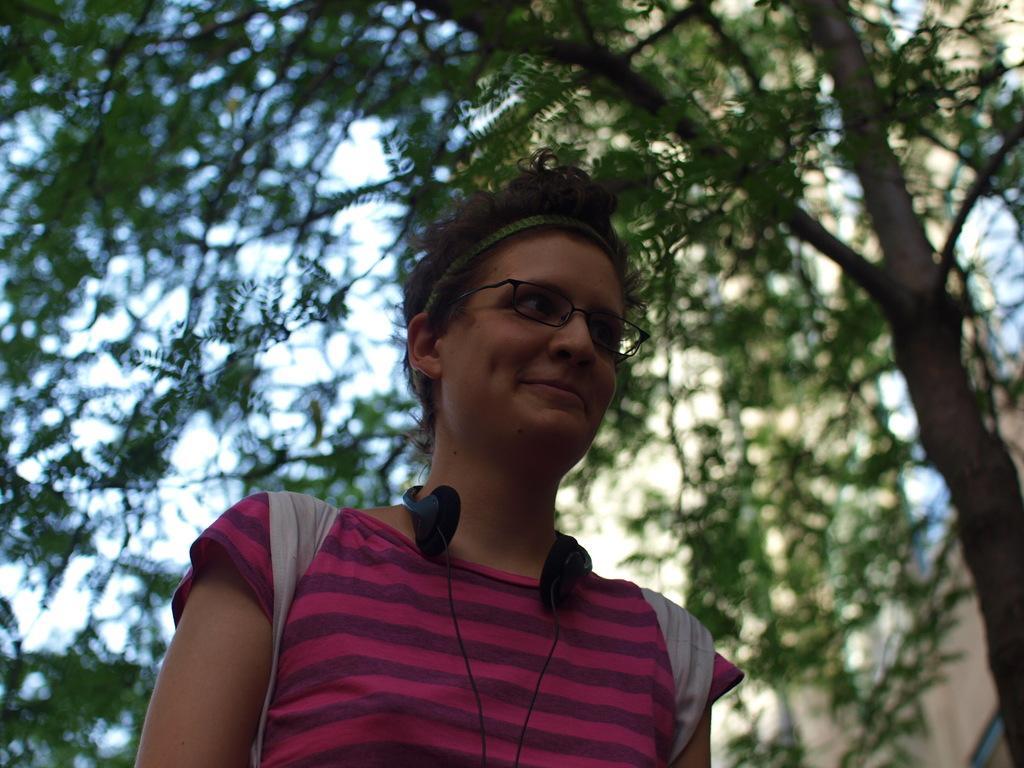Describe this image in one or two sentences. In this picture we can see a person,wearing a spectacles,headphones and we can see trees,sky in the background. 